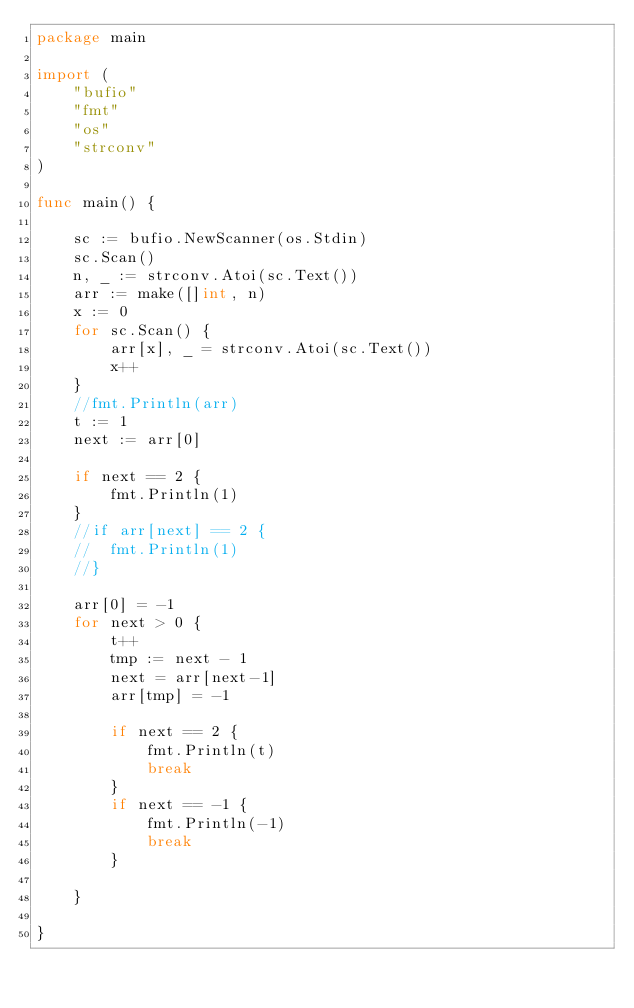<code> <loc_0><loc_0><loc_500><loc_500><_Go_>package main

import (
	"bufio"
	"fmt"
	"os"
	"strconv"
)

func main() {

	sc := bufio.NewScanner(os.Stdin)
	sc.Scan()
	n, _ := strconv.Atoi(sc.Text())
	arr := make([]int, n)
	x := 0
	for sc.Scan() {
		arr[x], _ = strconv.Atoi(sc.Text())
		x++
	}
	//fmt.Println(arr)
	t := 1
	next := arr[0]

	if next == 2 {
		fmt.Println(1)
	}
	//if arr[next] == 2 {
	//	fmt.Println(1)
	//}

	arr[0] = -1
	for next > 0 {
		t++
		tmp := next - 1
		next = arr[next-1]
		arr[tmp] = -1

		if next == 2 {
			fmt.Println(t)
			break
		}
		if next == -1 {
			fmt.Println(-1)
			break
		}

	}

}
</code> 